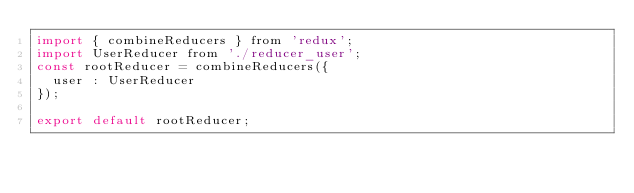Convert code to text. <code><loc_0><loc_0><loc_500><loc_500><_JavaScript_>import { combineReducers } from 'redux';
import UserReducer from './reducer_user';
const rootReducer = combineReducers({
  user : UserReducer
});

export default rootReducer;</code> 